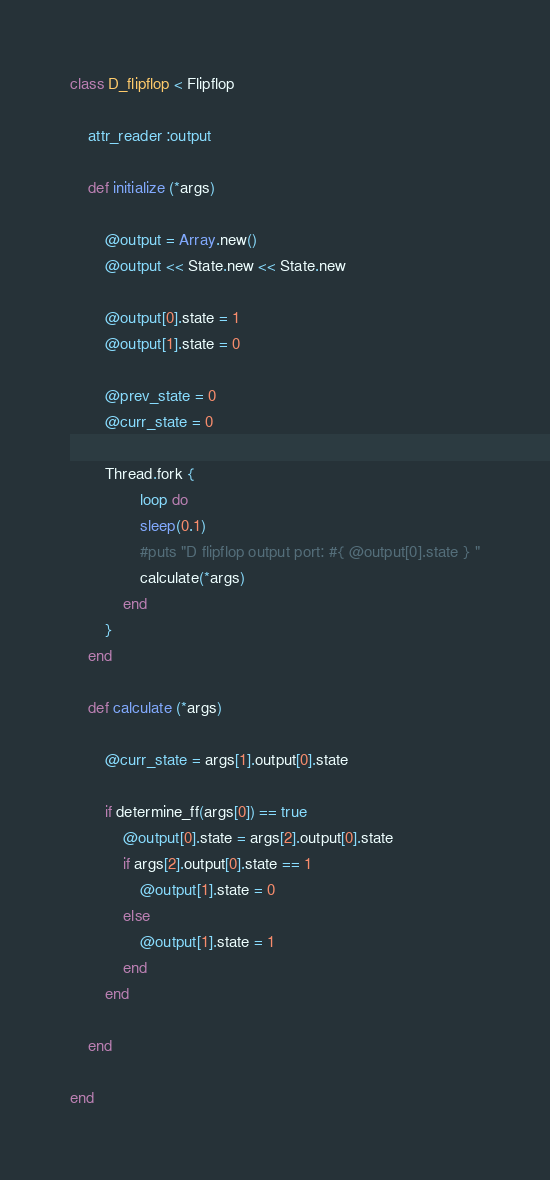Convert code to text. <code><loc_0><loc_0><loc_500><loc_500><_Ruby_>class D_flipflop < Flipflop

    attr_reader :output 

    def initialize (*args)

        @output = Array.new()
        @output << State.new << State.new

        @output[0].state = 1
        @output[1].state = 0

        @prev_state = 0
        @curr_state = 0
        
        Thread.fork {
                loop do
                sleep(0.1)
                #puts "D flipflop output port: #{ @output[0].state } "
                calculate(*args)
            end       
        }
    end

    def calculate (*args)      
    
        @curr_state = args[1].output[0].state
        
        if determine_ff(args[0]) == true
            @output[0].state = args[2].output[0].state
            if args[2].output[0].state == 1
                @output[1].state = 0
            else 
                @output[1].state = 1
            end
        end

    end

end
</code> 